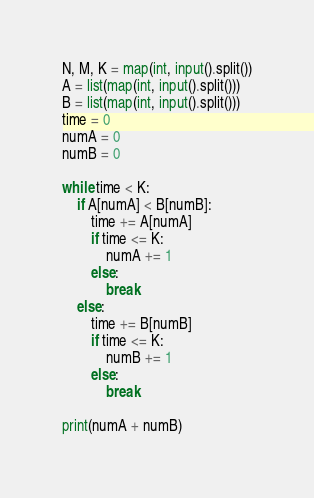Convert code to text. <code><loc_0><loc_0><loc_500><loc_500><_Python_>N, M, K = map(int, input().split())
A = list(map(int, input().split()))
B = list(map(int, input().split()))
time = 0
numA = 0
numB = 0

while time < K:
    if A[numA] < B[numB]:
        time += A[numA]
        if time <= K:
            numA += 1
        else:
            break
    else:
        time += B[numB]
        if time <= K:
            numB += 1
        else:
            break

print(numA + numB)</code> 